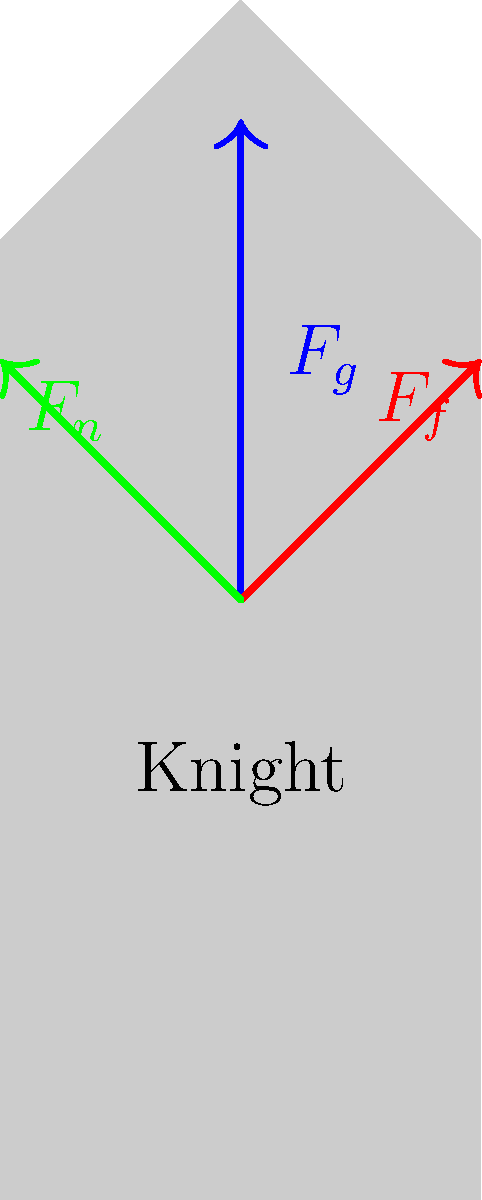During a medieval reenactment in Warstein, a knight in full plate armor is walking on a slightly inclined surface. Given that the total mass of the knight and armor is 150 kg, the incline is 10°, and the coefficient of friction between the armor and the surface is 0.3, calculate the magnitude of the frictional force acting on the knight. To solve this problem, we'll follow these steps:

1. Identify the forces acting on the knight:
   - Gravity ($F_g$)
   - Normal force ($F_n$)
   - Frictional force ($F_f$)

2. Calculate the force of gravity:
   $F_g = mg = 150 \text{ kg} \times 9.8 \text{ m/s}^2 = 1470 \text{ N}$

3. Resolve the force of gravity into components parallel and perpendicular to the incline:
   - Parallel component: $F_g \sin(10°) = 1470 \text{ N} \times \sin(10°) = 255.17 \text{ N}$
   - Perpendicular component: $F_g \cos(10°) = 1470 \text{ N} \times \cos(10°) = 1447.34 \text{ N}$

4. The normal force ($F_n$) is equal to the perpendicular component of gravity:
   $F_n = 1447.34 \text{ N}$

5. Calculate the maximum static friction force:
   $F_f = \mu F_n = 0.3 \times 1447.34 \text{ N} = 434.20 \text{ N}$

6. Compare the frictional force to the parallel component of gravity:
   Since $434.20 \text{ N} > 255.17 \text{ N}$, the frictional force is sufficient to prevent the knight from sliding down the incline.

7. The actual frictional force acting on the knight is equal to the parallel component of gravity:
   $F_f = 255.17 \text{ N}$
Answer: 255.17 N 